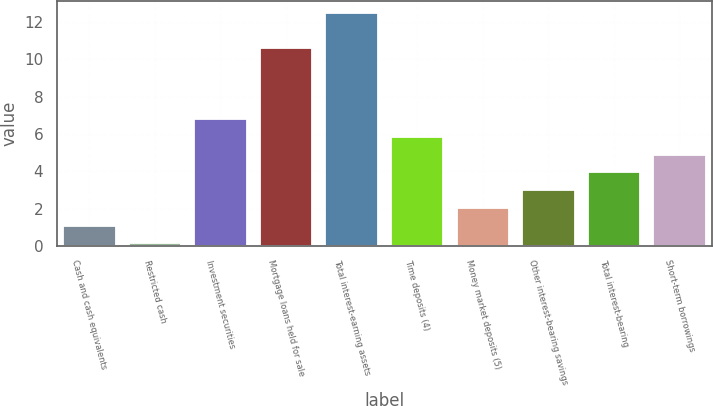Convert chart. <chart><loc_0><loc_0><loc_500><loc_500><bar_chart><fcel>Cash and cash equivalents<fcel>Restricted cash<fcel>Investment securities<fcel>Mortgage loans held for sale<fcel>Total interest-earning assets<fcel>Time deposits (4)<fcel>Money market deposits (5)<fcel>Other interest-bearing savings<fcel>Total interest-bearing<fcel>Short-term borrowings<nl><fcel>1.09<fcel>0.14<fcel>6.79<fcel>10.59<fcel>12.49<fcel>5.84<fcel>2.04<fcel>2.99<fcel>3.94<fcel>4.89<nl></chart> 